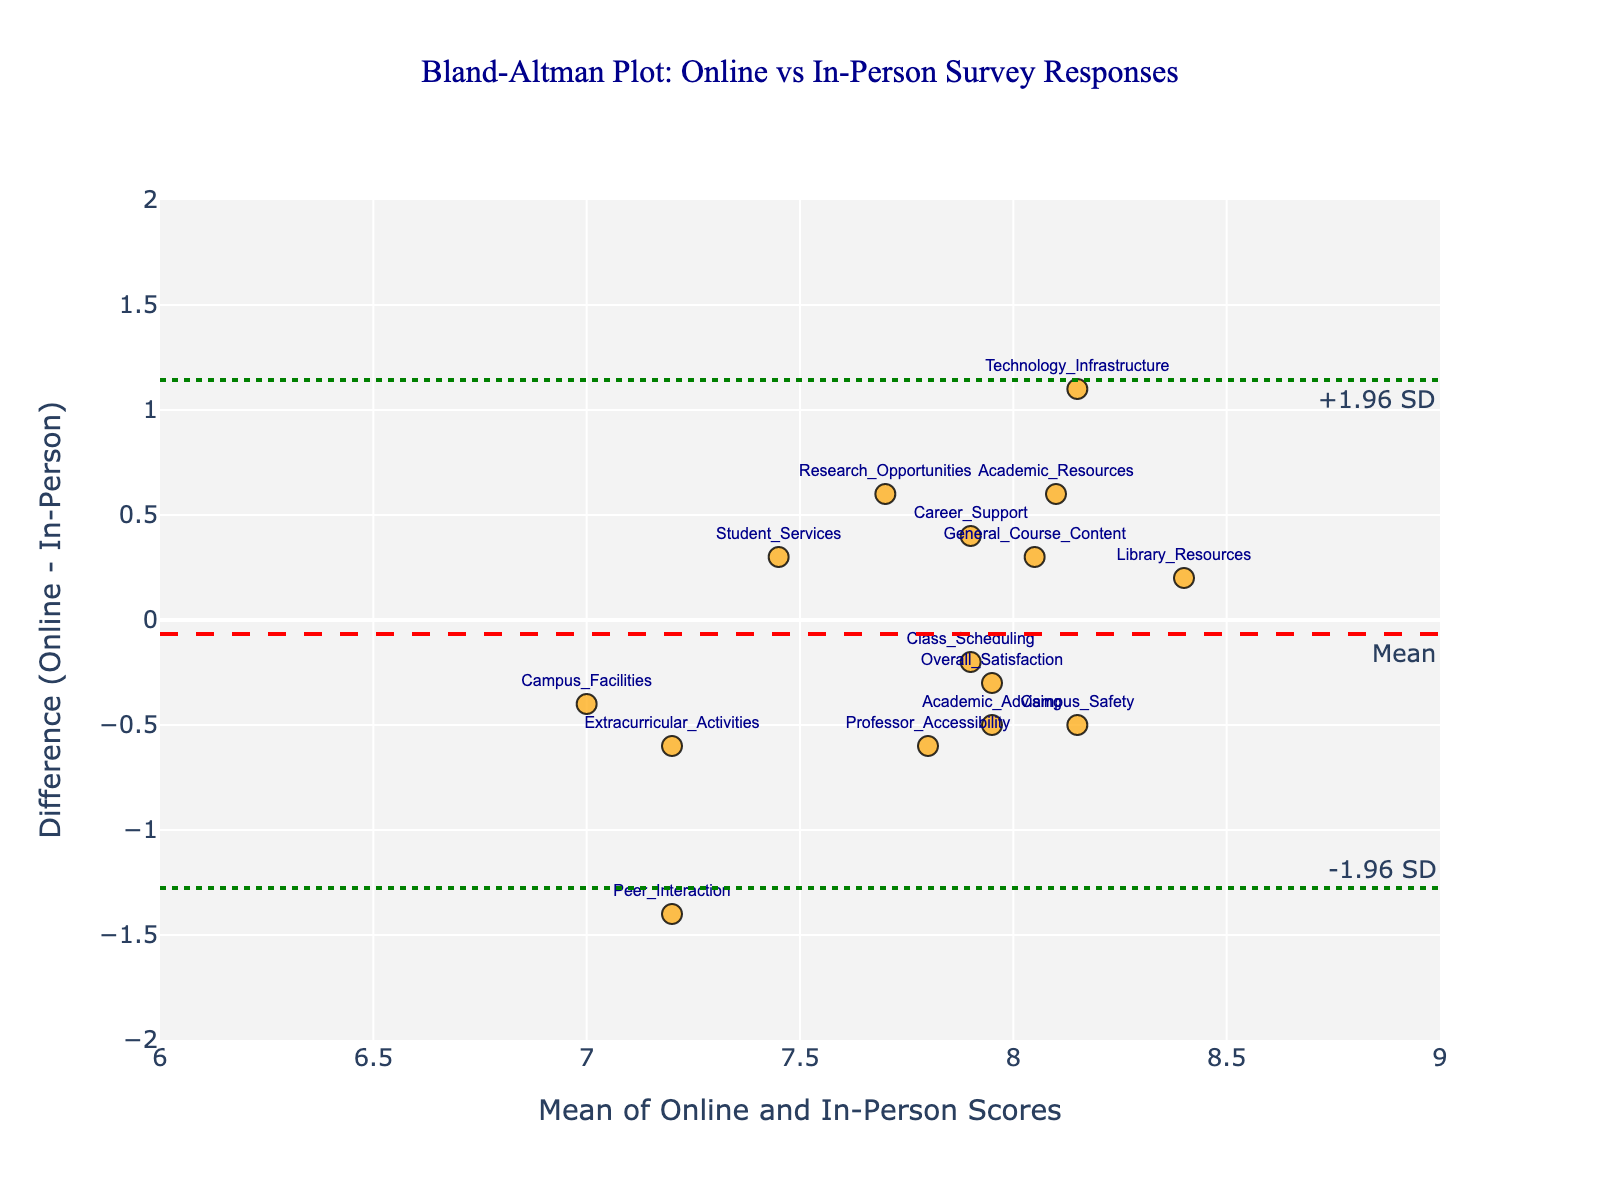What is the title of the plot? The title is given at the top of the figure, which reads "Bland-Altman Plot: Online vs In-Person Survey Responses".
Answer: Bland-Altman Plot: Online vs In-Person Survey Responses What are the labels of the x-axis and y-axis? The x-axis is labeled "Mean of Online and In-Person Scores" and the y-axis is labeled "Difference (Online - In-Person)".
Answer: Mean of Online and In-Person Scores; Difference (Online - In-Person) How many data points are plotted in the figure, and what is their general appearance? There are 15 data points plotted in the figure. Each data point is represented as an orange marker with a black outline, and text labels identifying each method.
Answer: 15 What is the range of the x-axis and the y-axis? The x-axis ranges from 6 to 9 with tick intervals of 0.5, and the y-axis ranges from -2 to 2 with tick intervals of 0.5.
Answer: X-axis: 6 to 9; Y-axis: -2 to 2 What is the mean difference line value on the y-axis, and how is it annotated? The mean difference line is at a value of approximately 0.1 on the y-axis, and it is annotated with the text "Mean" and a red dashed line.
Answer: 0.1 How are the upper and lower limits of agreement represented in the plot, and what are their approximate values? The upper limit of agreement is represented as a green dot line labeled "+1.96 SD" at approximately 1.2, and the lower limit of agreement is represented as another green dot line labeled "-1.96 SD" at approximately -1.0.
Answer: Upper: 1.2; Lower: -1.0 Which data point has the highest positive difference, and what is its value? The data point "Technology_Infrastructure" has the highest positive difference with a y-axis value of approximately 1.1.
Answer: Technology_Infrastructure, 1.1 Which data point has the highest mean score, and what is its value? The data point "Technology_Infrastructure" has the highest mean score with an x-axis value of approximately 8.15.
Answer: Technology_Infrastructure, 8.15 Which method shows the smallest difference (closest to zero), and what is the value of that difference? The method "Library_Resources" shows the smallest difference, with a value of -0.2.
Answer: Library_Resources, -0.2 Are there any data points where the difference is below the lower limit of agreement? No, all the data points fall within the limits of agreement.
Answer: No 